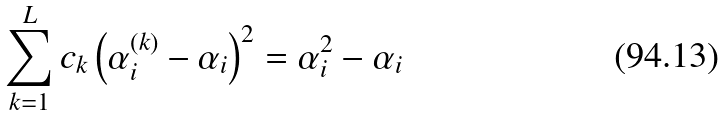<formula> <loc_0><loc_0><loc_500><loc_500>\sum _ { k = 1 } ^ { L } c _ { k } \left ( \alpha _ { i } ^ { ( k ) } - \alpha _ { i } \right ) ^ { 2 } = \alpha _ { i } ^ { 2 } - \alpha _ { i }</formula> 